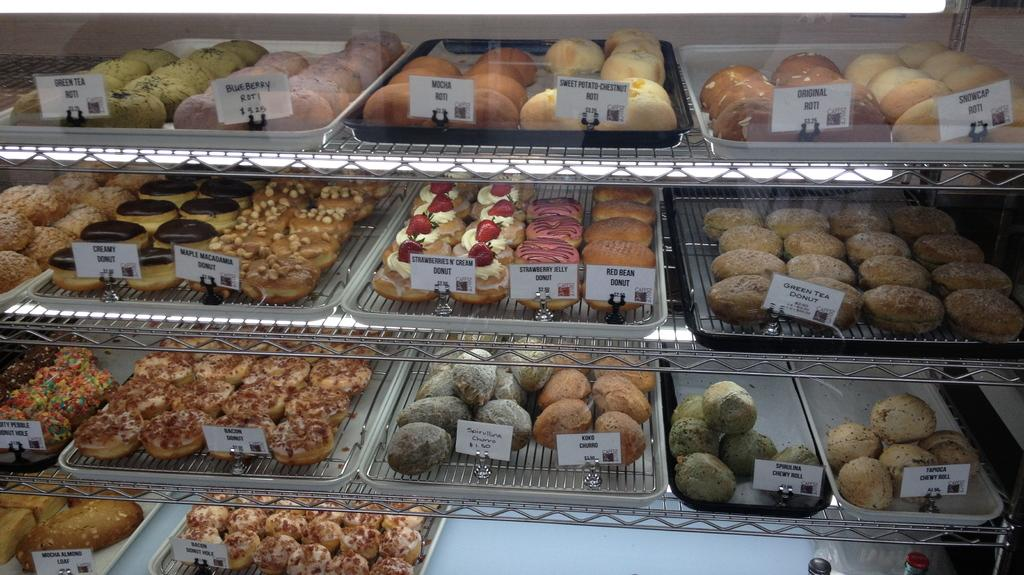What type of food items can be seen in the image? There are baked items in the image. How are the baked items arranged in the image? The baked items are arranged in a rack. Can you tell me the price of any of the baked items in the image? Each baked item has a tag price in the image. What type of beast can be seen in the image? There is no beast present in the image; it features baked items arranged in a rack with tag prices. Can you tell me how the hose is connected to the baked items in the image? There is no hose present in the image; it only features baked items, a rack, and tag prices. 